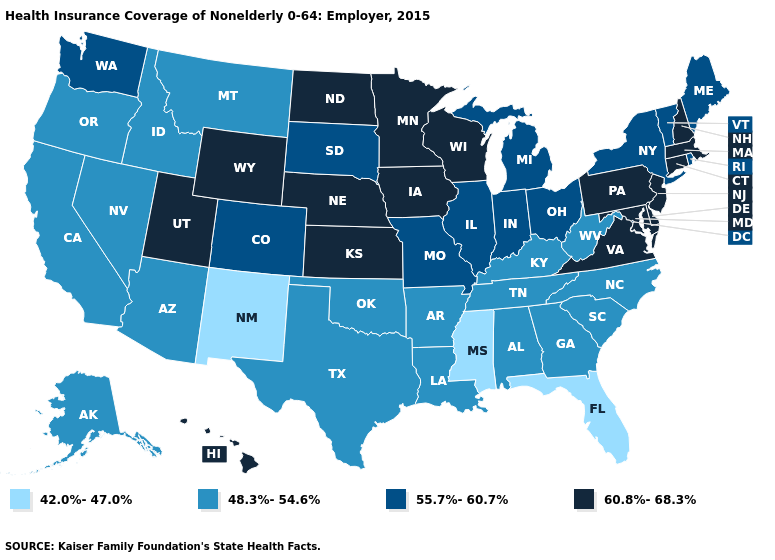Does Idaho have the same value as Maine?
Be succinct. No. Does the first symbol in the legend represent the smallest category?
Be succinct. Yes. How many symbols are there in the legend?
Concise answer only. 4. Does New Jersey have the highest value in the Northeast?
Concise answer only. Yes. What is the highest value in the USA?
Concise answer only. 60.8%-68.3%. What is the value of West Virginia?
Give a very brief answer. 48.3%-54.6%. Name the states that have a value in the range 60.8%-68.3%?
Give a very brief answer. Connecticut, Delaware, Hawaii, Iowa, Kansas, Maryland, Massachusetts, Minnesota, Nebraska, New Hampshire, New Jersey, North Dakota, Pennsylvania, Utah, Virginia, Wisconsin, Wyoming. Is the legend a continuous bar?
Answer briefly. No. Does Delaware have the highest value in the USA?
Quick response, please. Yes. Does Connecticut have the highest value in the Northeast?
Write a very short answer. Yes. What is the value of Arkansas?
Give a very brief answer. 48.3%-54.6%. What is the value of Tennessee?
Short answer required. 48.3%-54.6%. Does the first symbol in the legend represent the smallest category?
Give a very brief answer. Yes. Which states have the highest value in the USA?
Concise answer only. Connecticut, Delaware, Hawaii, Iowa, Kansas, Maryland, Massachusetts, Minnesota, Nebraska, New Hampshire, New Jersey, North Dakota, Pennsylvania, Utah, Virginia, Wisconsin, Wyoming. Among the states that border Tennessee , which have the lowest value?
Short answer required. Mississippi. 